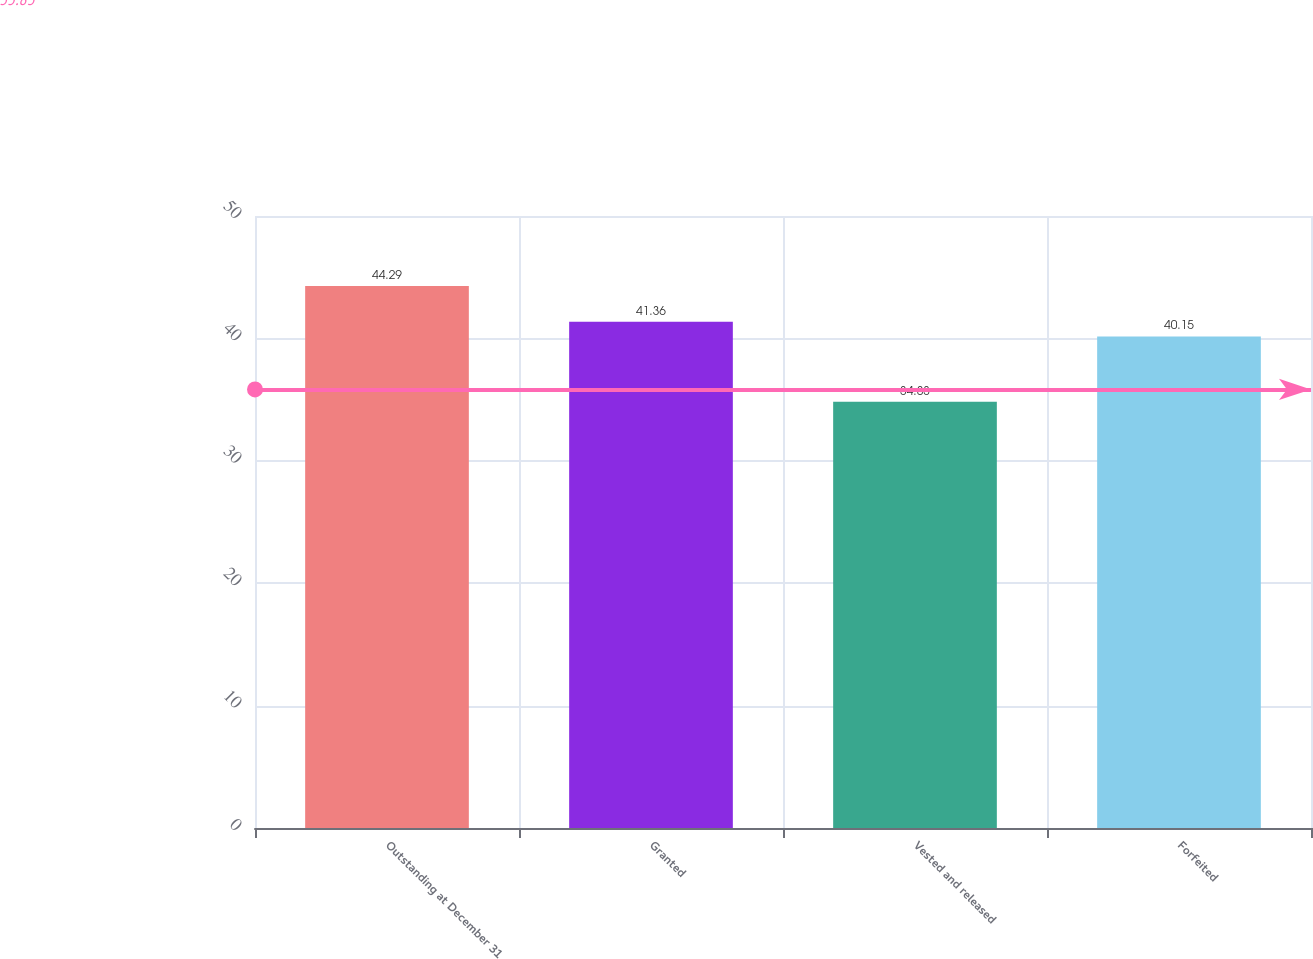Convert chart to OTSL. <chart><loc_0><loc_0><loc_500><loc_500><bar_chart><fcel>Outstanding at December 31<fcel>Granted<fcel>Vested and released<fcel>Forfeited<nl><fcel>44.29<fcel>41.36<fcel>34.83<fcel>40.15<nl></chart> 